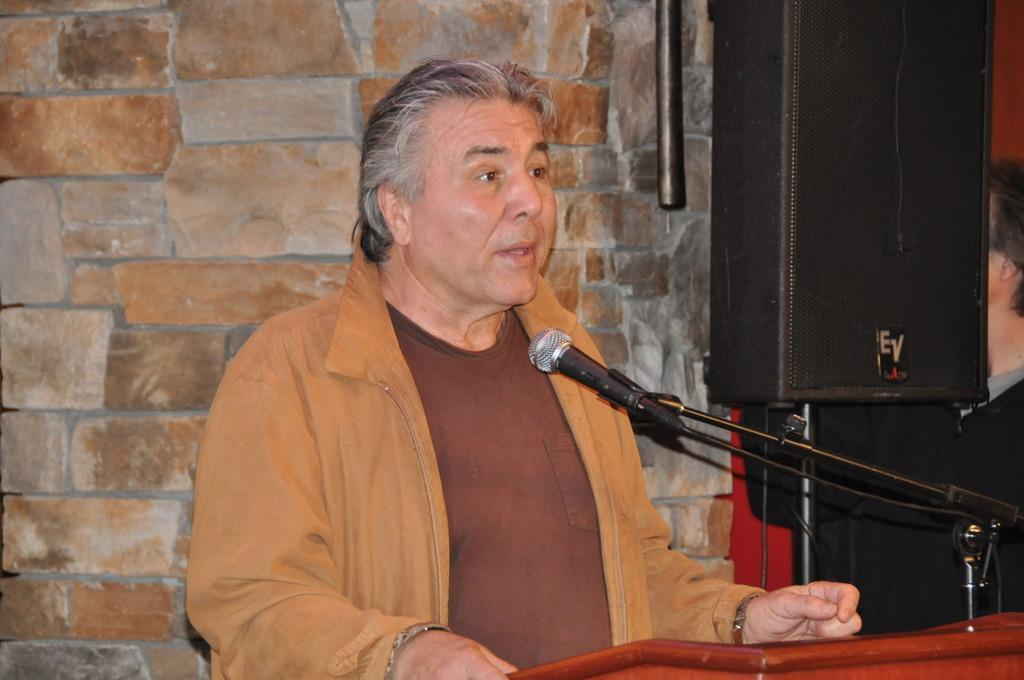Who is the main subject in the image? There is an old man in the image. What is the old man wearing? The old man is wearing a brown jacket. Where is the old man standing in the image? The old man is standing in front of a dias. What is the old man doing in the image? The old man is talking on a mic. What can be seen on the left side of the image? There is a wall on the left side of the image. What can be seen on the right side of the image? There is a speaker on the right side of the image. What type of fowl can be seen sitting on the old man's shoulder in the image? There is no fowl present on the old man's shoulder in the image. What type of hearing aid is the old man using in the image? The old man is talking on a mic, but there is no mention of a hearing aid in the image. 